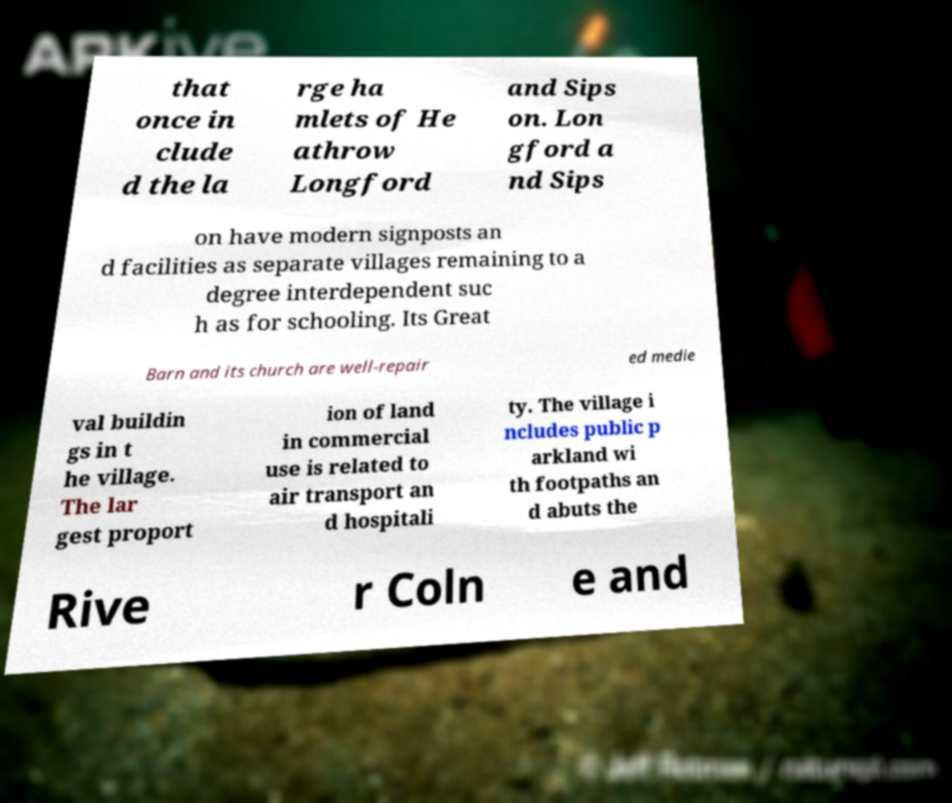What messages or text are displayed in this image? I need them in a readable, typed format. that once in clude d the la rge ha mlets of He athrow Longford and Sips on. Lon gford a nd Sips on have modern signposts an d facilities as separate villages remaining to a degree interdependent suc h as for schooling. Its Great Barn and its church are well-repair ed medie val buildin gs in t he village. The lar gest proport ion of land in commercial use is related to air transport an d hospitali ty. The village i ncludes public p arkland wi th footpaths an d abuts the Rive r Coln e and 